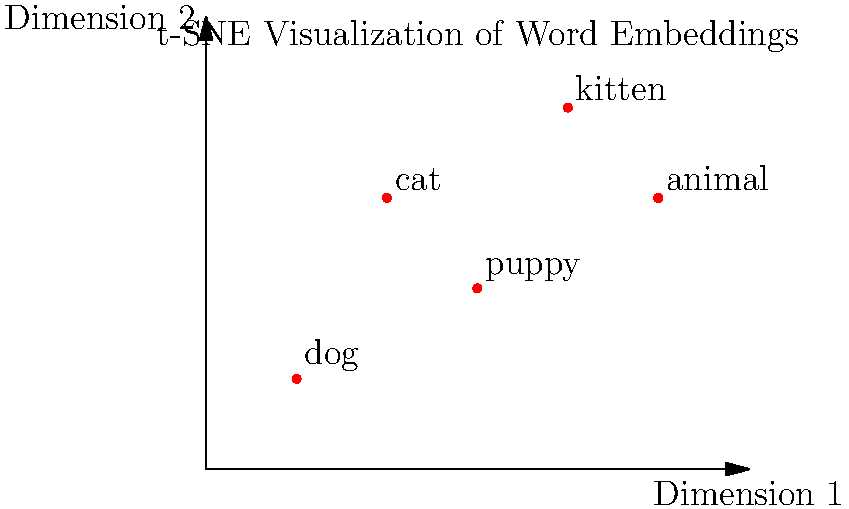In the t-SNE visualization of word embeddings shown above, which two words are likely to have the most similar semantic meaning based on their proximity in the 2D space? To determine which two words have the most similar semantic meaning based on their proximity in the t-SNE visualization, we need to follow these steps:

1. Understand the principle: In t-SNE visualizations of word embeddings, words with similar meanings tend to cluster together in the reduced dimensional space.

2. Identify the word positions:
   - "dog" is at (0,0)
   - "cat" is at (1,2)
   - "puppy" is at (2,1)
   - "kitten" is at (3,3)
   - "animal" is at (4,2)

3. Calculate distances between points:
   We don't need to calculate exact distances, but we can visually estimate which points are closest to each other.

4. Compare proximities:
   - "dog" and "puppy" appear to be the closest pair
   - "cat" and "kitten" are also relatively close
   - "animal" is somewhat central but not particularly close to any other word

5. Consider semantic relationships:
   The closest pair, "dog" and "puppy", also makes sense semantically as they refer to the same animal at different life stages.

Therefore, based on both their proximity in the 2D space and their semantic relationship, "dog" and "puppy" are likely to have the most similar semantic meaning.
Answer: dog and puppy 